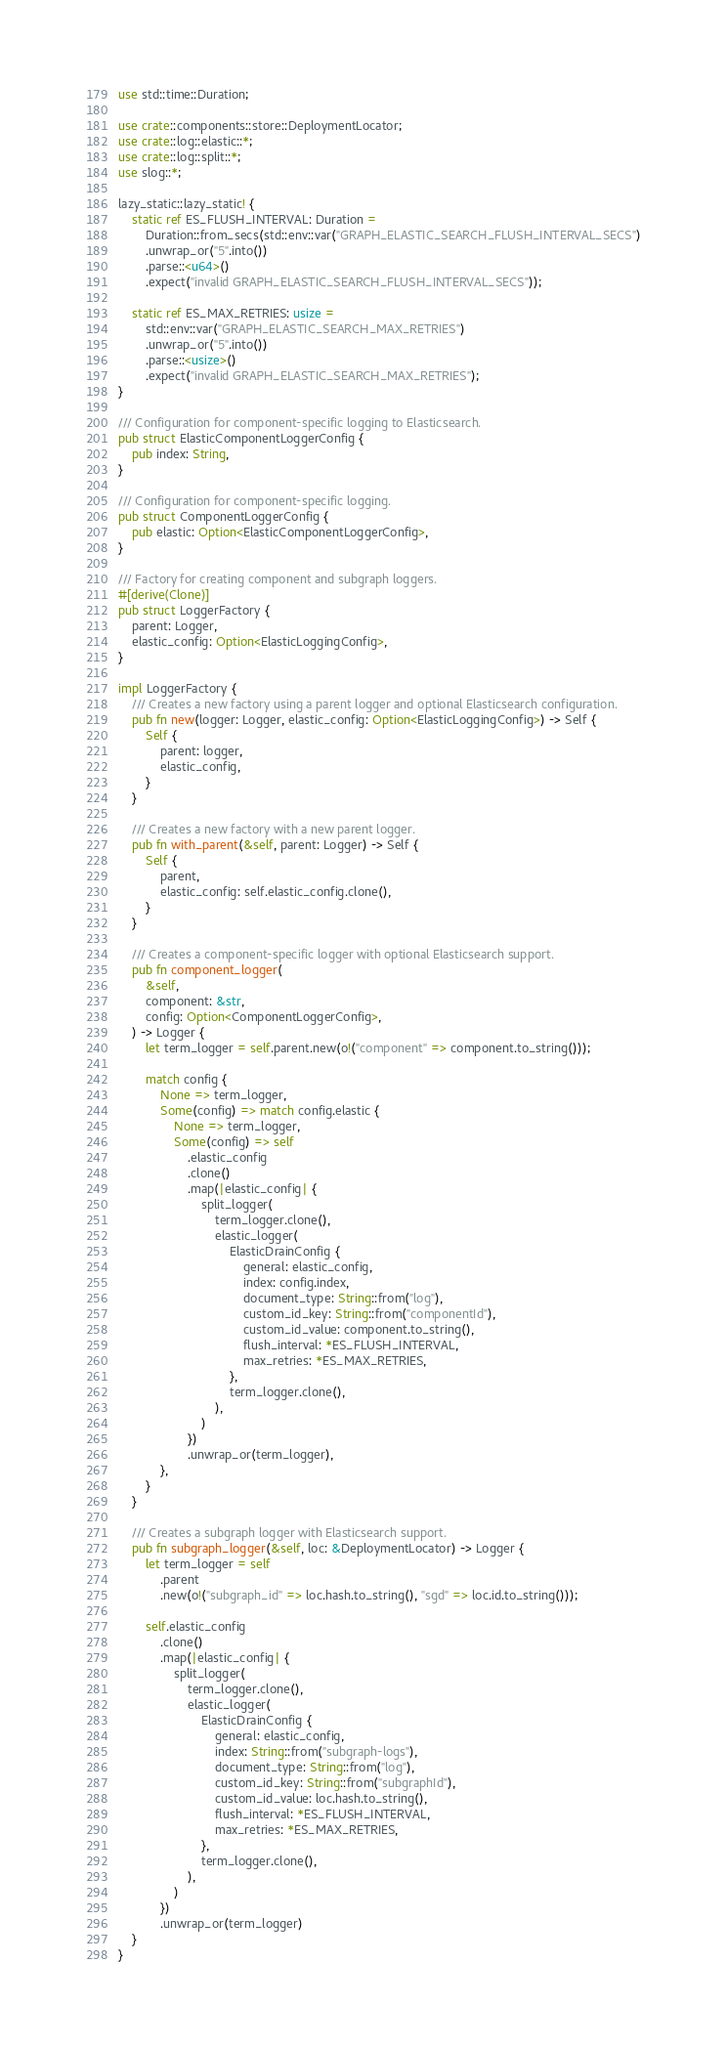<code> <loc_0><loc_0><loc_500><loc_500><_Rust_>use std::time::Duration;

use crate::components::store::DeploymentLocator;
use crate::log::elastic::*;
use crate::log::split::*;
use slog::*;

lazy_static::lazy_static! {
    static ref ES_FLUSH_INTERVAL: Duration =
        Duration::from_secs(std::env::var("GRAPH_ELASTIC_SEARCH_FLUSH_INTERVAL_SECS")
        .unwrap_or("5".into())
        .parse::<u64>()
        .expect("invalid GRAPH_ELASTIC_SEARCH_FLUSH_INTERVAL_SECS"));

    static ref ES_MAX_RETRIES: usize =
        std::env::var("GRAPH_ELASTIC_SEARCH_MAX_RETRIES")
        .unwrap_or("5".into())
        .parse::<usize>()
        .expect("invalid GRAPH_ELASTIC_SEARCH_MAX_RETRIES");
}

/// Configuration for component-specific logging to Elasticsearch.
pub struct ElasticComponentLoggerConfig {
    pub index: String,
}

/// Configuration for component-specific logging.
pub struct ComponentLoggerConfig {
    pub elastic: Option<ElasticComponentLoggerConfig>,
}

/// Factory for creating component and subgraph loggers.
#[derive(Clone)]
pub struct LoggerFactory {
    parent: Logger,
    elastic_config: Option<ElasticLoggingConfig>,
}

impl LoggerFactory {
    /// Creates a new factory using a parent logger and optional Elasticsearch configuration.
    pub fn new(logger: Logger, elastic_config: Option<ElasticLoggingConfig>) -> Self {
        Self {
            parent: logger,
            elastic_config,
        }
    }

    /// Creates a new factory with a new parent logger.
    pub fn with_parent(&self, parent: Logger) -> Self {
        Self {
            parent,
            elastic_config: self.elastic_config.clone(),
        }
    }

    /// Creates a component-specific logger with optional Elasticsearch support.
    pub fn component_logger(
        &self,
        component: &str,
        config: Option<ComponentLoggerConfig>,
    ) -> Logger {
        let term_logger = self.parent.new(o!("component" => component.to_string()));

        match config {
            None => term_logger,
            Some(config) => match config.elastic {
                None => term_logger,
                Some(config) => self
                    .elastic_config
                    .clone()
                    .map(|elastic_config| {
                        split_logger(
                            term_logger.clone(),
                            elastic_logger(
                                ElasticDrainConfig {
                                    general: elastic_config,
                                    index: config.index,
                                    document_type: String::from("log"),
                                    custom_id_key: String::from("componentId"),
                                    custom_id_value: component.to_string(),
                                    flush_interval: *ES_FLUSH_INTERVAL,
                                    max_retries: *ES_MAX_RETRIES,
                                },
                                term_logger.clone(),
                            ),
                        )
                    })
                    .unwrap_or(term_logger),
            },
        }
    }

    /// Creates a subgraph logger with Elasticsearch support.
    pub fn subgraph_logger(&self, loc: &DeploymentLocator) -> Logger {
        let term_logger = self
            .parent
            .new(o!("subgraph_id" => loc.hash.to_string(), "sgd" => loc.id.to_string()));

        self.elastic_config
            .clone()
            .map(|elastic_config| {
                split_logger(
                    term_logger.clone(),
                    elastic_logger(
                        ElasticDrainConfig {
                            general: elastic_config,
                            index: String::from("subgraph-logs"),
                            document_type: String::from("log"),
                            custom_id_key: String::from("subgraphId"),
                            custom_id_value: loc.hash.to_string(),
                            flush_interval: *ES_FLUSH_INTERVAL,
                            max_retries: *ES_MAX_RETRIES,
                        },
                        term_logger.clone(),
                    ),
                )
            })
            .unwrap_or(term_logger)
    }
}
</code> 